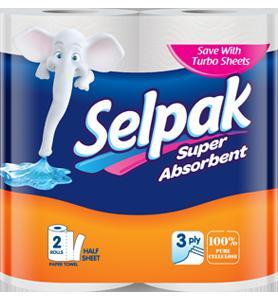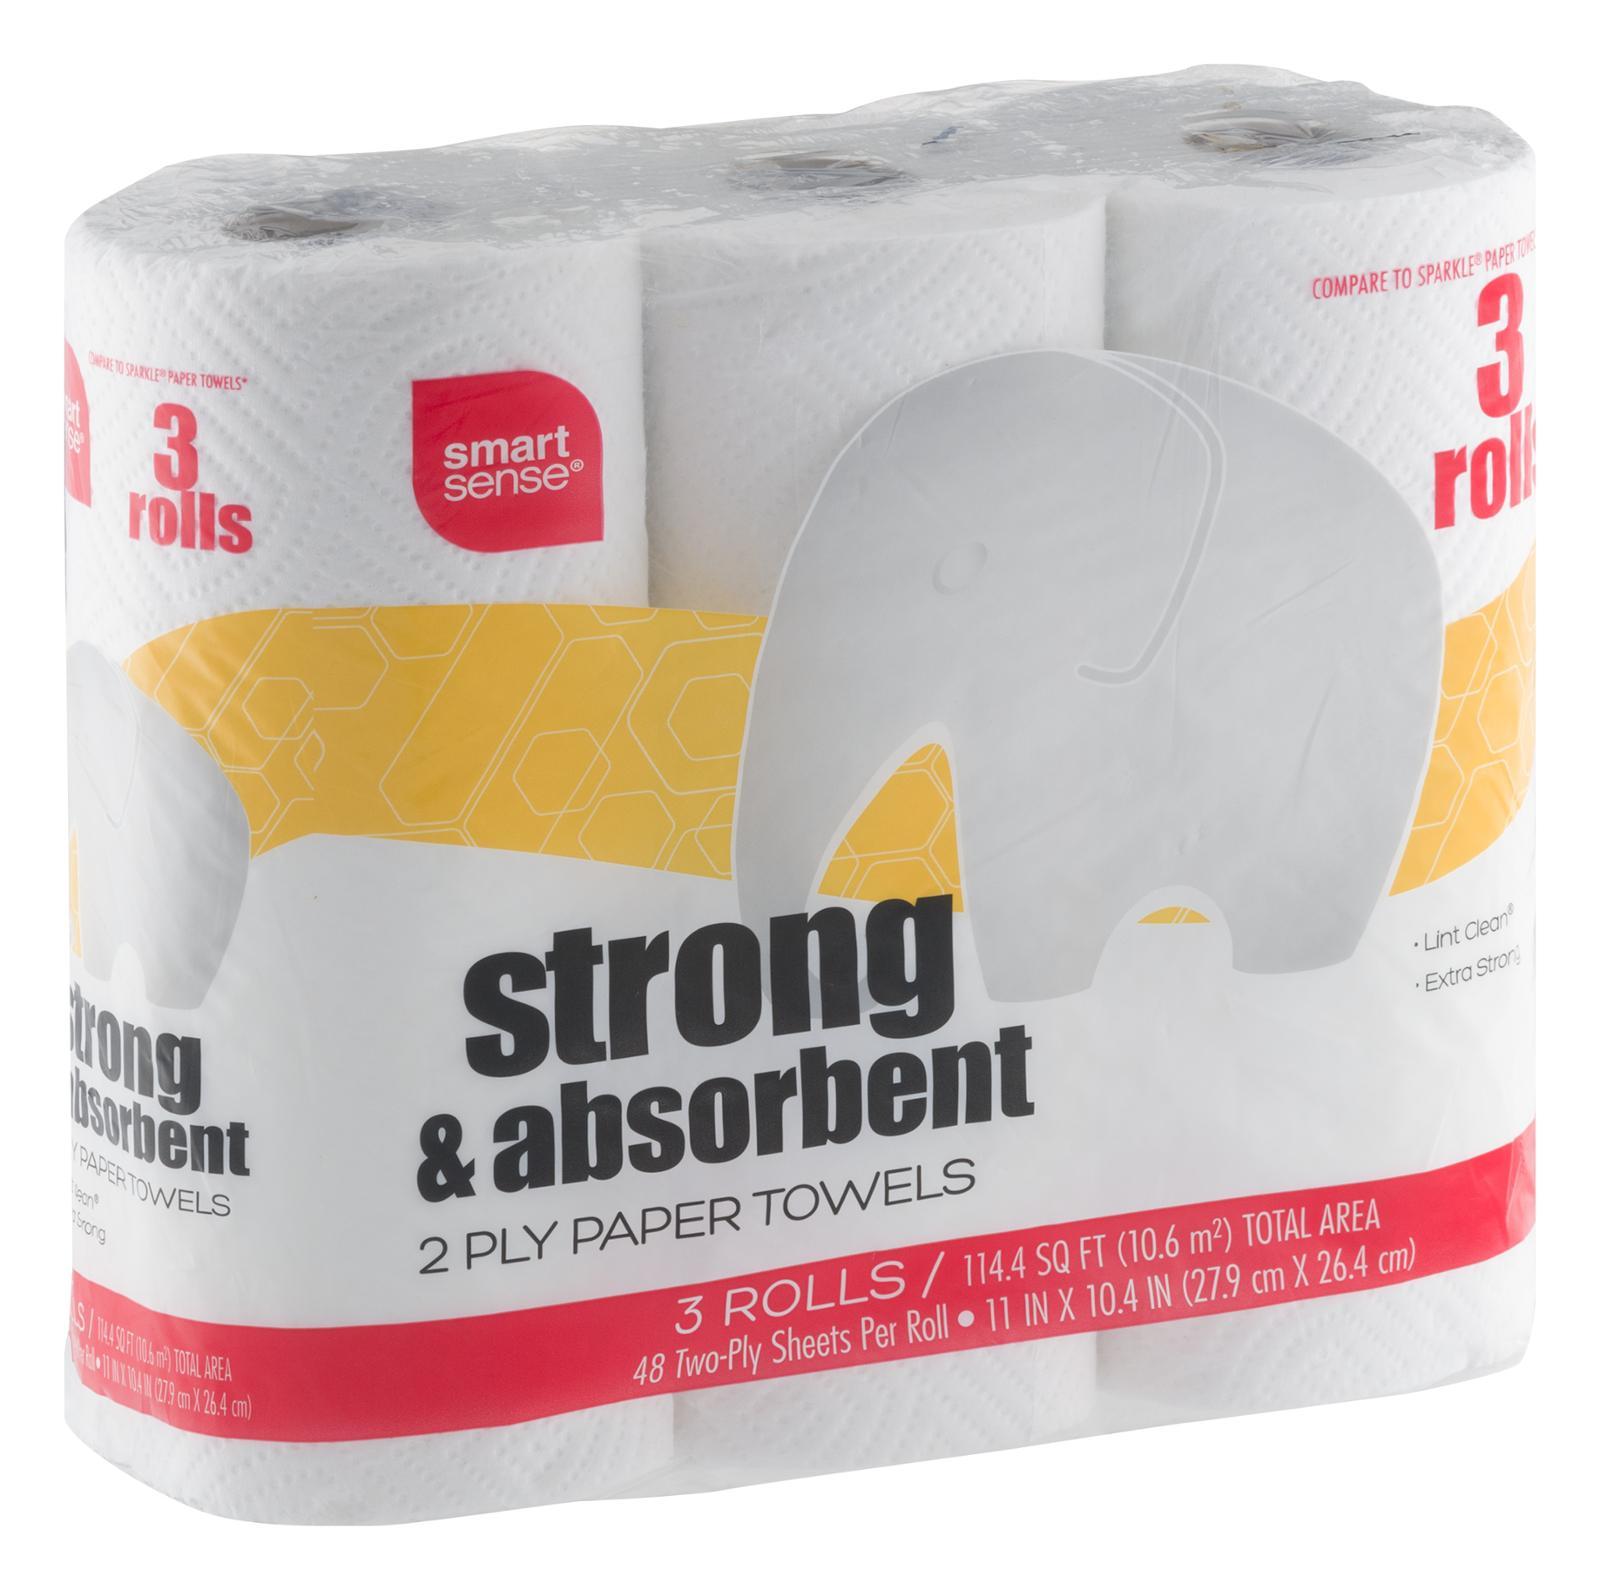The first image is the image on the left, the second image is the image on the right. Examine the images to the left and right. Is the description "Each image shows only a sealed package of paper towels and no package contains more than three rolls." accurate? Answer yes or no. Yes. The first image is the image on the left, the second image is the image on the right. Given the left and right images, does the statement "An image includes some amount of paper towel that is not in its wrapped package." hold true? Answer yes or no. No. 